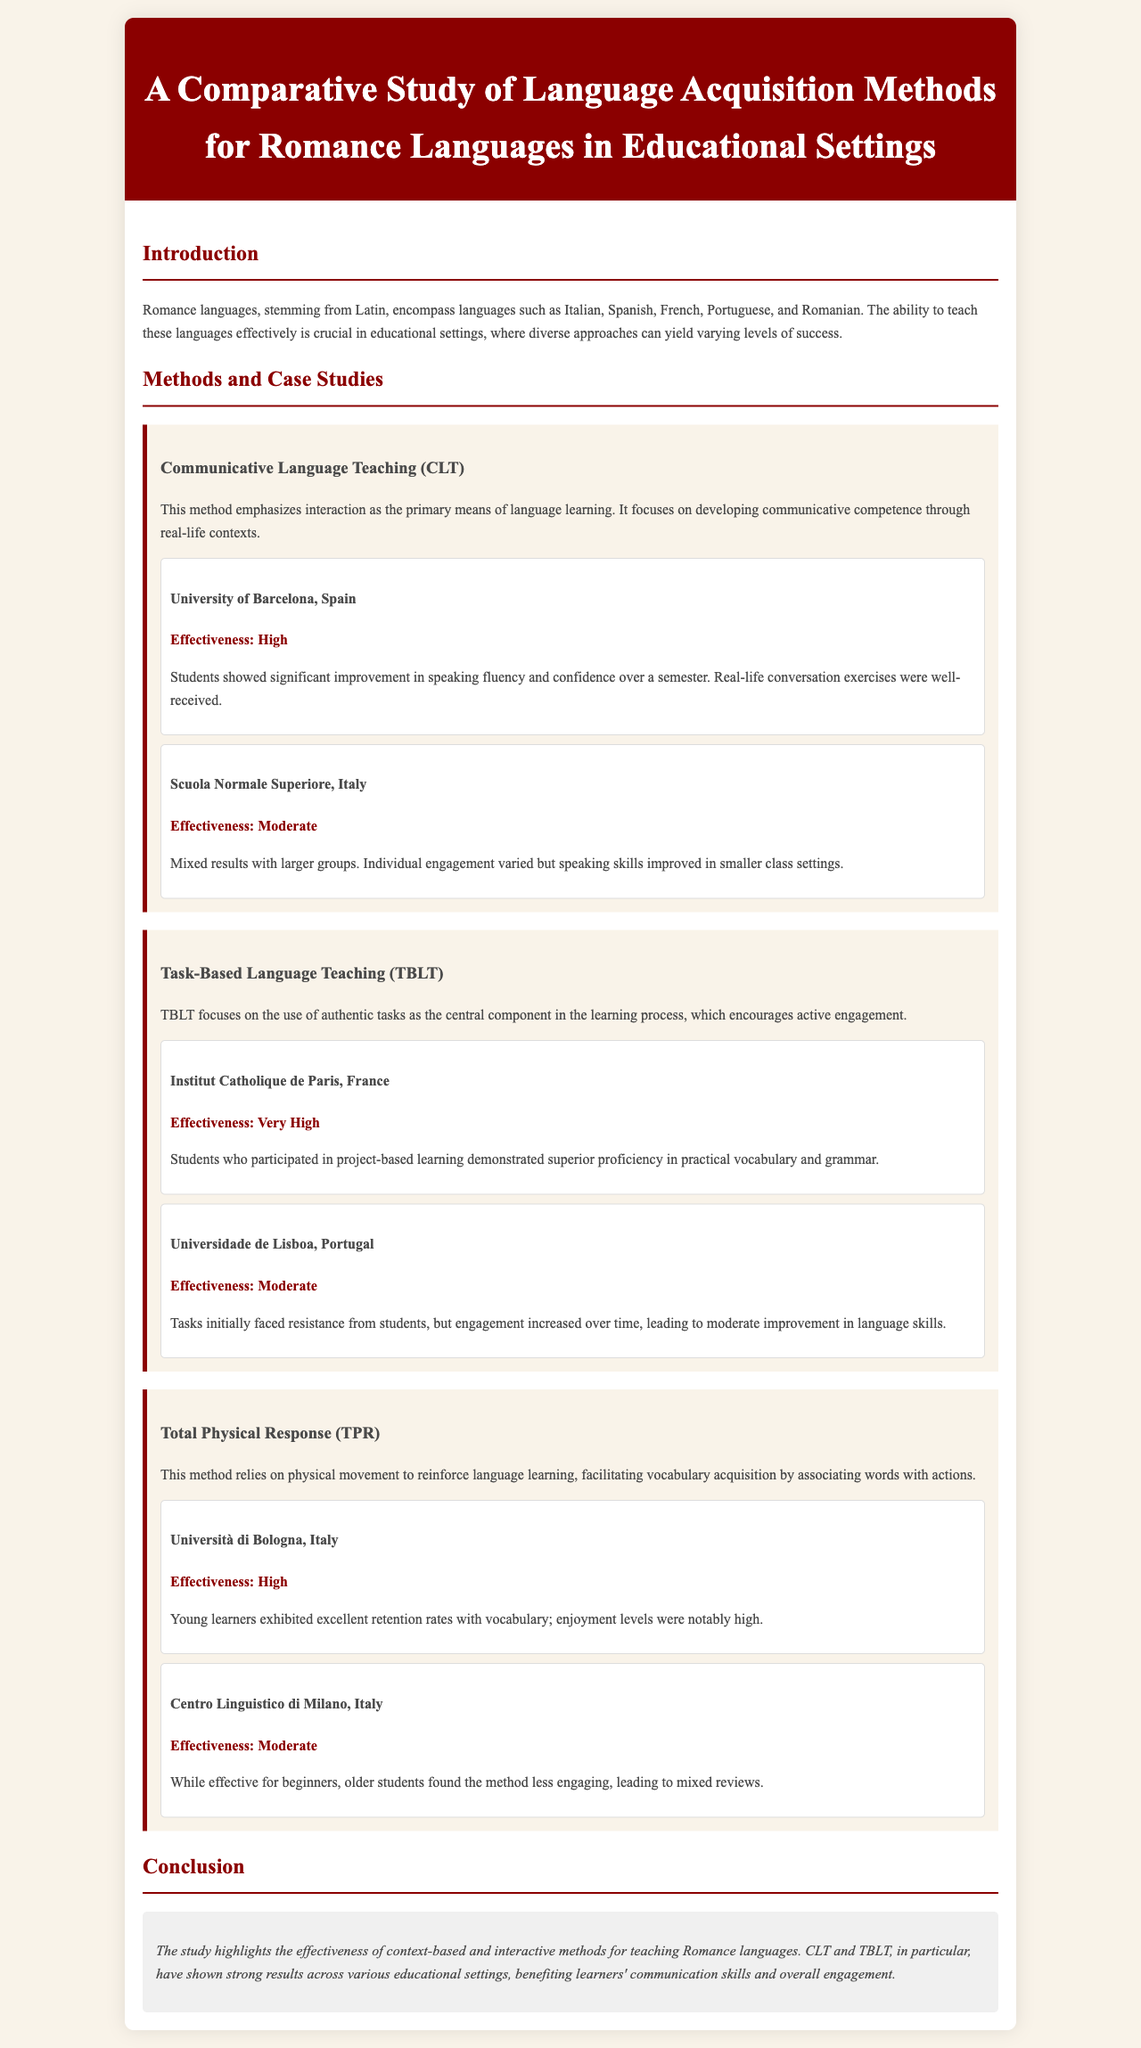what is the title of the study? The title is stated prominently in the header of the document, which is "A Comparative Study of Language Acquisition Methods for Romance Languages in Educational Settings."
Answer: A Comparative Study of Language Acquisition Methods for Romance Languages in Educational Settings what method emphasizes interaction as the primary means of language learning? The method described that emphasizes interaction is called Communicative Language Teaching (CLT).
Answer: Communicative Language Teaching (CLT) which case study showed very high effectiveness? The case study at the Institut Catholique de Paris, France demonstrated very high effectiveness in the TBLT method.
Answer: Institut Catholique de Paris, France what language acquisition method is based on physical movement? The method that relies on physical movement to facilitate language learning is Total Physical Response (TPR).
Answer: Total Physical Response (TPR) which institution did not report high effectiveness in the study? The Scuola Normale Superiore, Italy reported moderate effectiveness in the Communicative Language Teaching method.
Answer: Scuola Normale Superiore, Italy what was noted about student engagement in Universidade de Lisboa? The engagement in Universidade de Lisboa initially faced resistance but improved over time in the Task-Based Language Teaching method.
Answer: Initially faced resistance but improved over time how many case studies were referenced in the Total Physical Response section? There are two case studies referenced in the Total Physical Response section, one from Università di Bologna and one from Centro Linguistico di Milano.
Answer: Two what overall recommendation does the conclusion make regarding teaching methods? The conclusion recommends context-based and interactive methods for teaching Romance languages.
Answer: Context-based and interactive methods what was the overall effectiveness rating for TBLT at the Institut Catholique de Paris? The overall effectiveness rating for TBLT at the Institut Catholique de Paris was rated as very high.
Answer: Very High which language was highlighted as a Romance language in the introduction? Italian is mentioned as one of the Romance languages stemming from Latin in the introduction.
Answer: Italian 